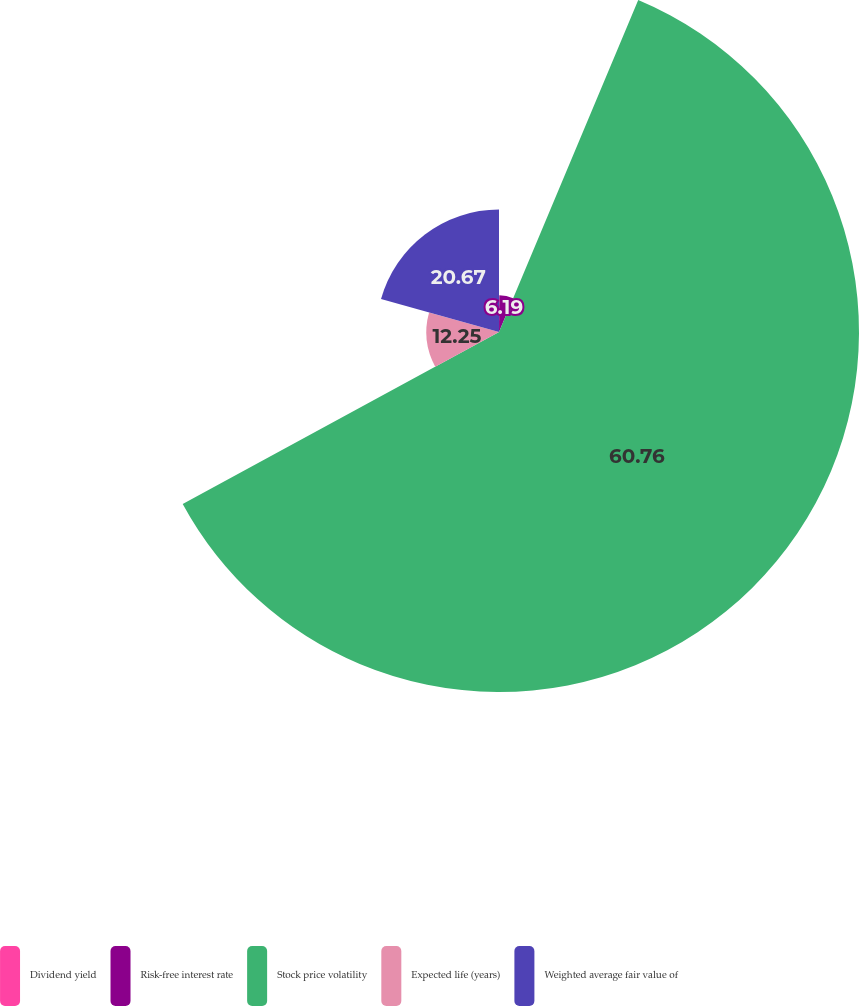Convert chart to OTSL. <chart><loc_0><loc_0><loc_500><loc_500><pie_chart><fcel>Dividend yield<fcel>Risk-free interest rate<fcel>Stock price volatility<fcel>Expected life (years)<fcel>Weighted average fair value of<nl><fcel>0.13%<fcel>6.19%<fcel>60.75%<fcel>12.25%<fcel>20.67%<nl></chart> 